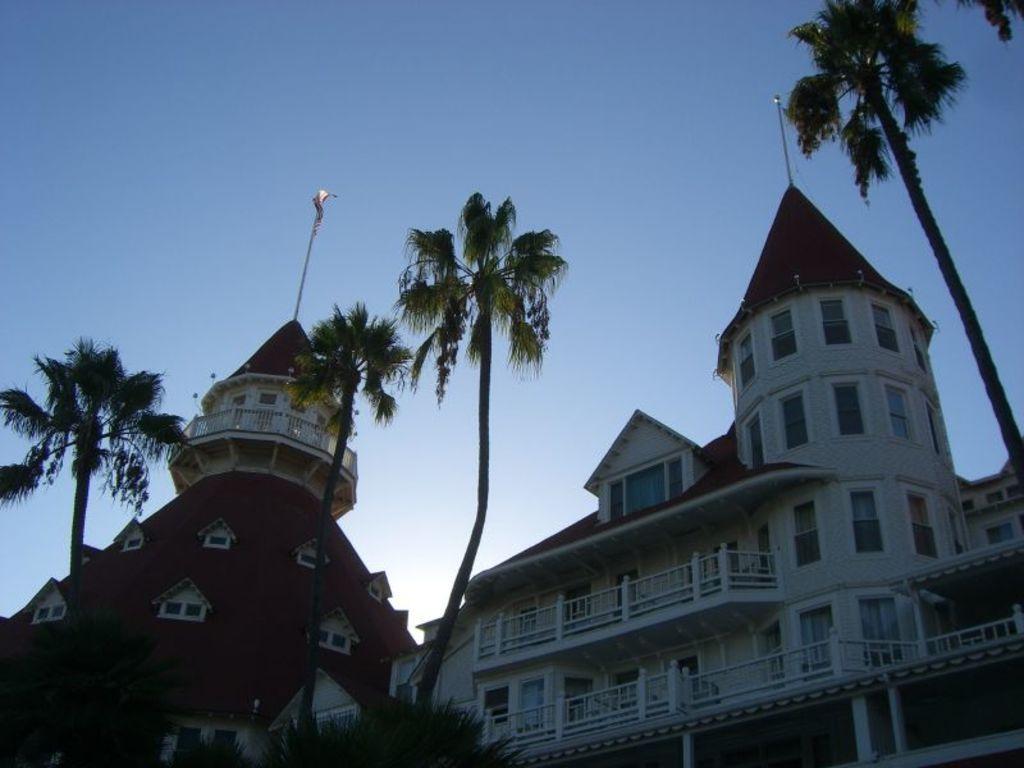How would you summarize this image in a sentence or two? In this image there are trees, in the background there is a palace and the sky. 